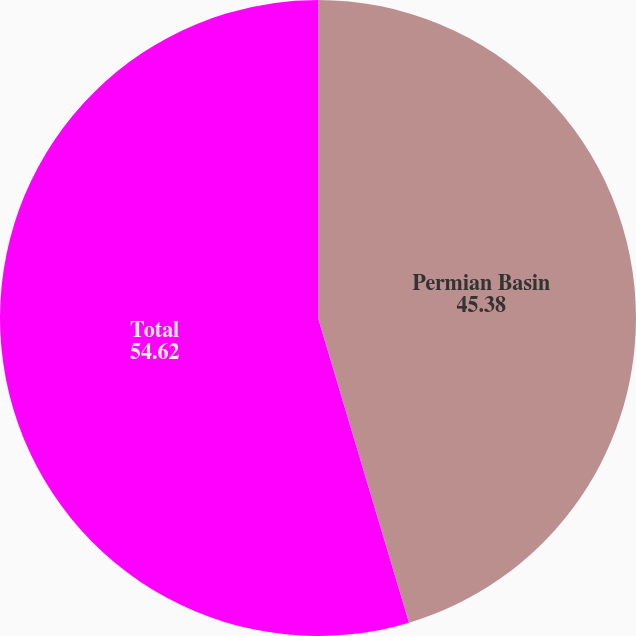Convert chart to OTSL. <chart><loc_0><loc_0><loc_500><loc_500><pie_chart><fcel>Permian Basin<fcel>Total<nl><fcel>45.38%<fcel>54.62%<nl></chart> 